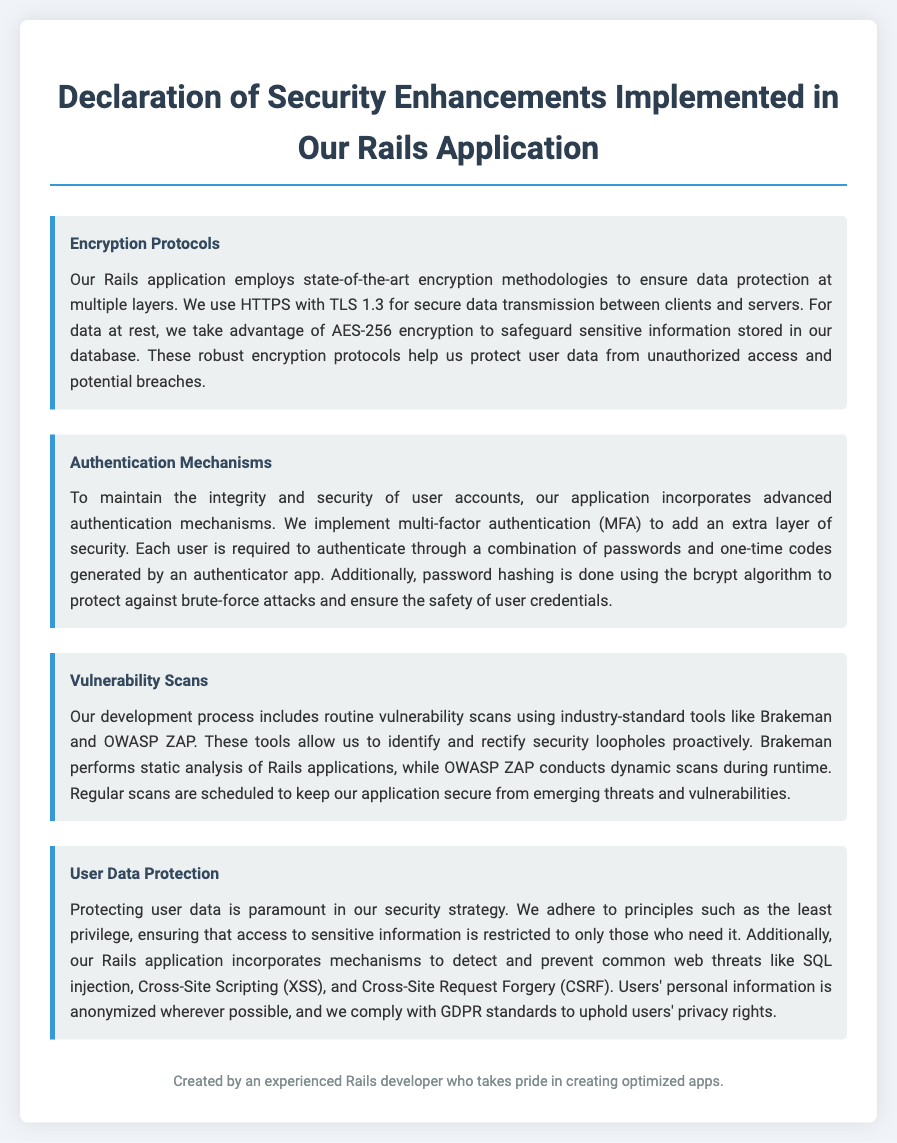What encryption protocols are used? The document states that HTTPS with TLS 1.3 and AES-256 encryption are used for secure data transmission and data at rest, respectively.
Answer: HTTPS with TLS 1.3 and AES-256 What authentication mechanism is implemented? The document mentions that multi-factor authentication (MFA) is used as an advanced authentication mechanism in the application.
Answer: Multi-factor authentication (MFA) Which tools are used for vulnerability scans? The document specifies that Brakeman and OWASP ZAP are the industry-standard tools utilized for conducting vulnerability scans.
Answer: Brakeman and OWASP ZAP What is the primary principle for user data access? The document highlights that the principle of least privilege is adhered to when restricting access to sensitive information.
Answer: Least privilege What algorithm is used for password hashing? The document states that the bcrypt algorithm is used for password hashing to protect against brute-force attacks.
Answer: bcrypt 